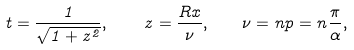Convert formula to latex. <formula><loc_0><loc_0><loc_500><loc_500>t = \frac { 1 } { \sqrt { 1 + z ^ { 2 } } } , \quad z = \frac { R x } { \nu } { , } \quad \nu = n p = n \frac { \pi } { \alpha } { , }</formula> 